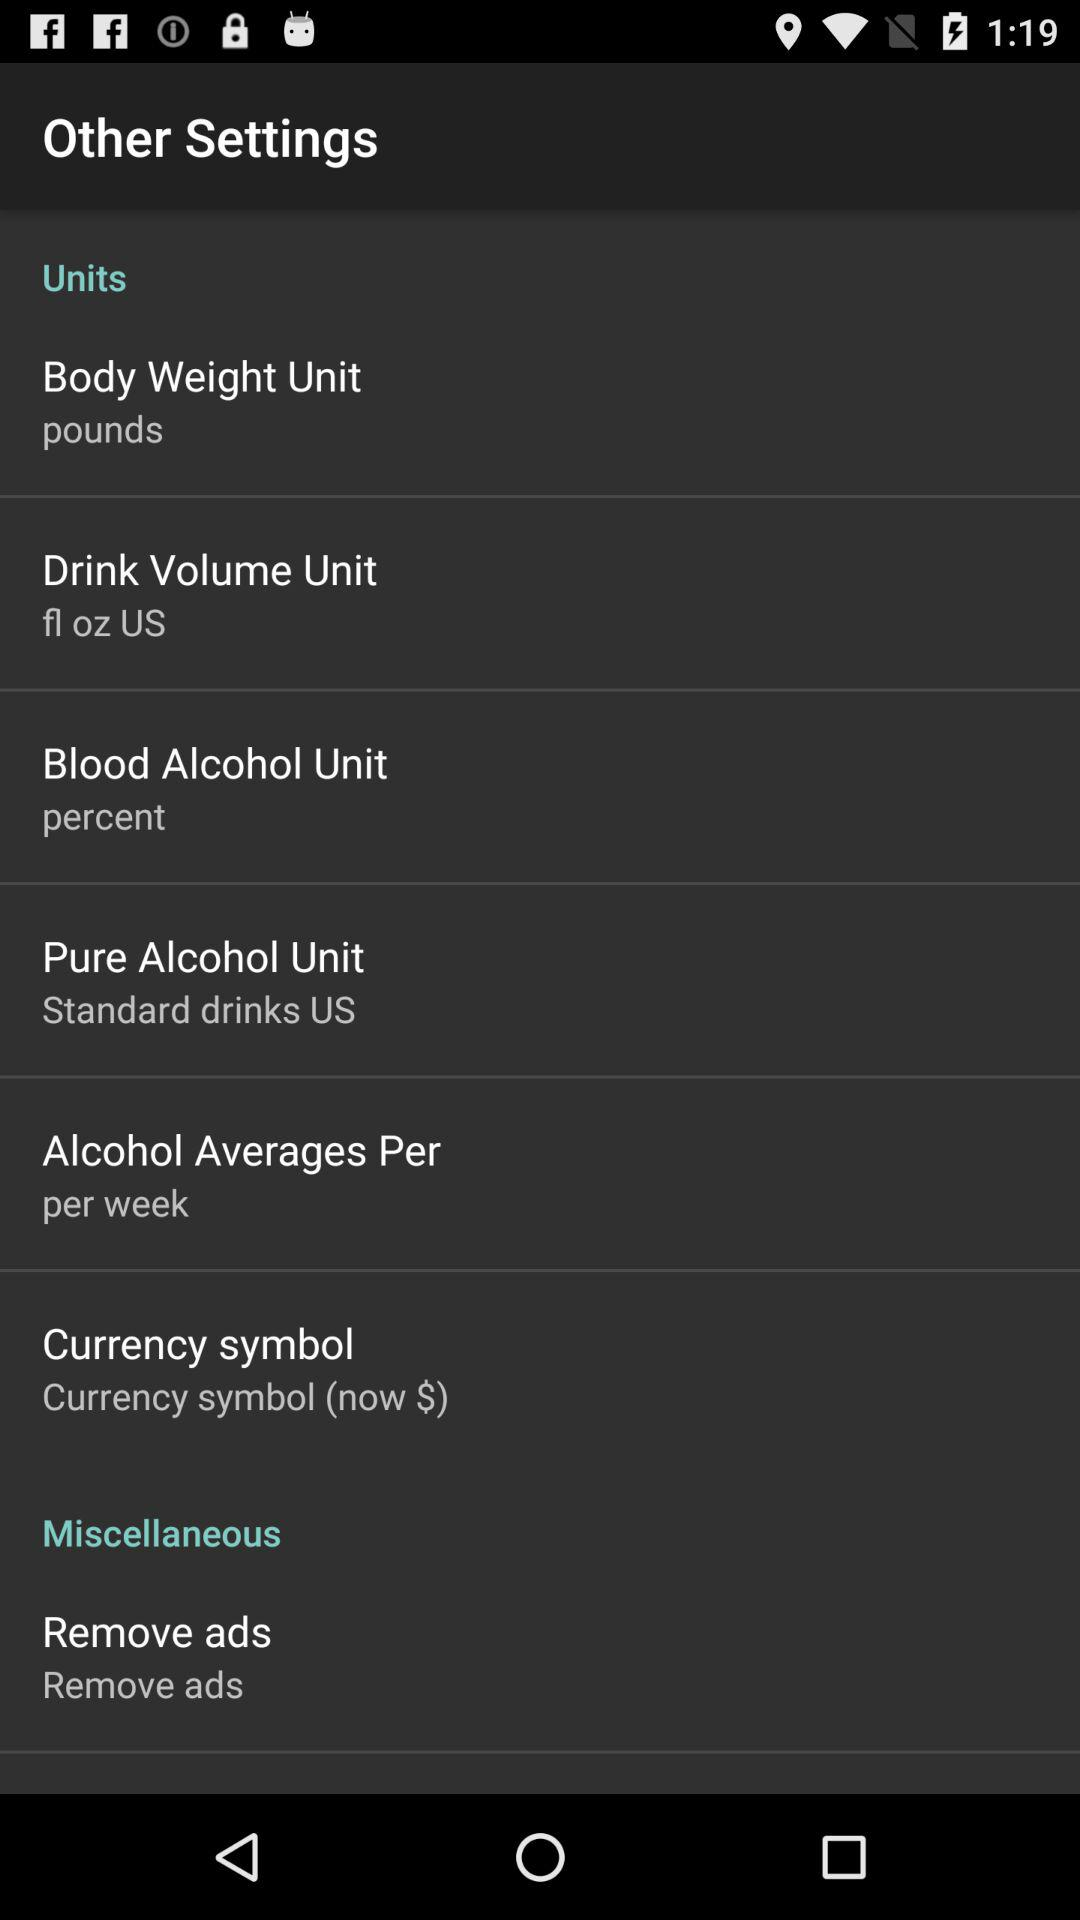What is the unit of drink volume? The unit of drink volume is fl oz. 